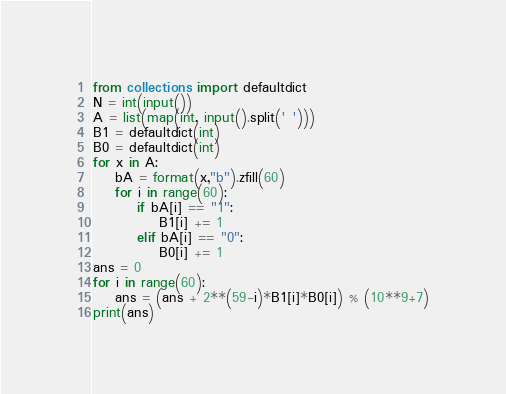<code> <loc_0><loc_0><loc_500><loc_500><_Python_>from collections import defaultdict
N = int(input())
A = list(map(int, input().split(' ')))
B1 = defaultdict(int)
B0 = defaultdict(int)
for x in A:
    bA = format(x,"b").zfill(60)
    for i in range(60):
        if bA[i] == "1":
            B1[i] += 1
        elif bA[i] == "0":
            B0[i] += 1
ans = 0
for i in range(60):
    ans = (ans + 2**(59-i)*B1[i]*B0[i]) % (10**9+7)
print(ans)</code> 